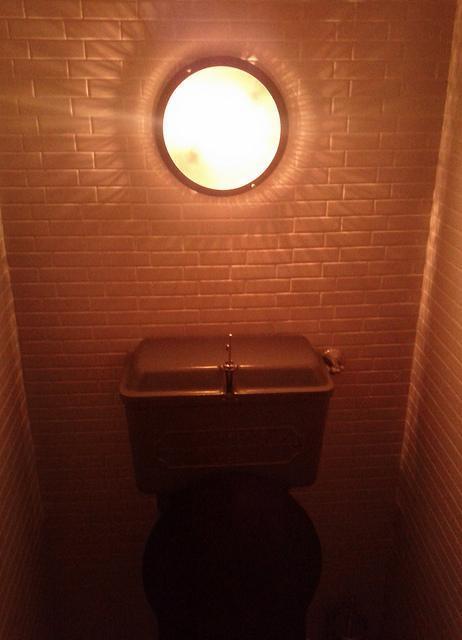How many toilets can you see?
Give a very brief answer. 1. How many suitcases are there in this picture?
Give a very brief answer. 0. 